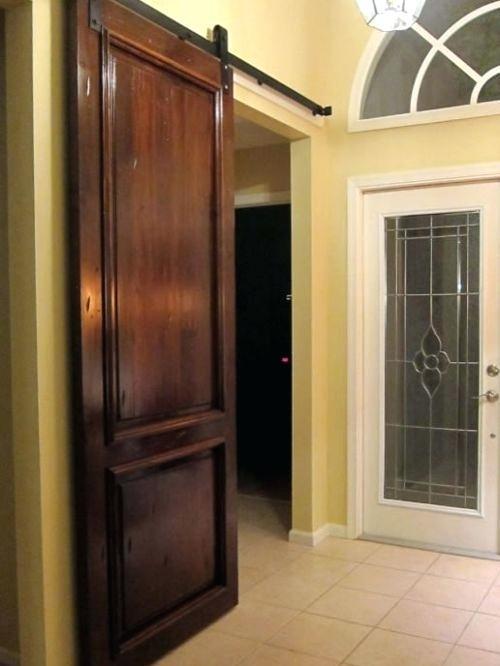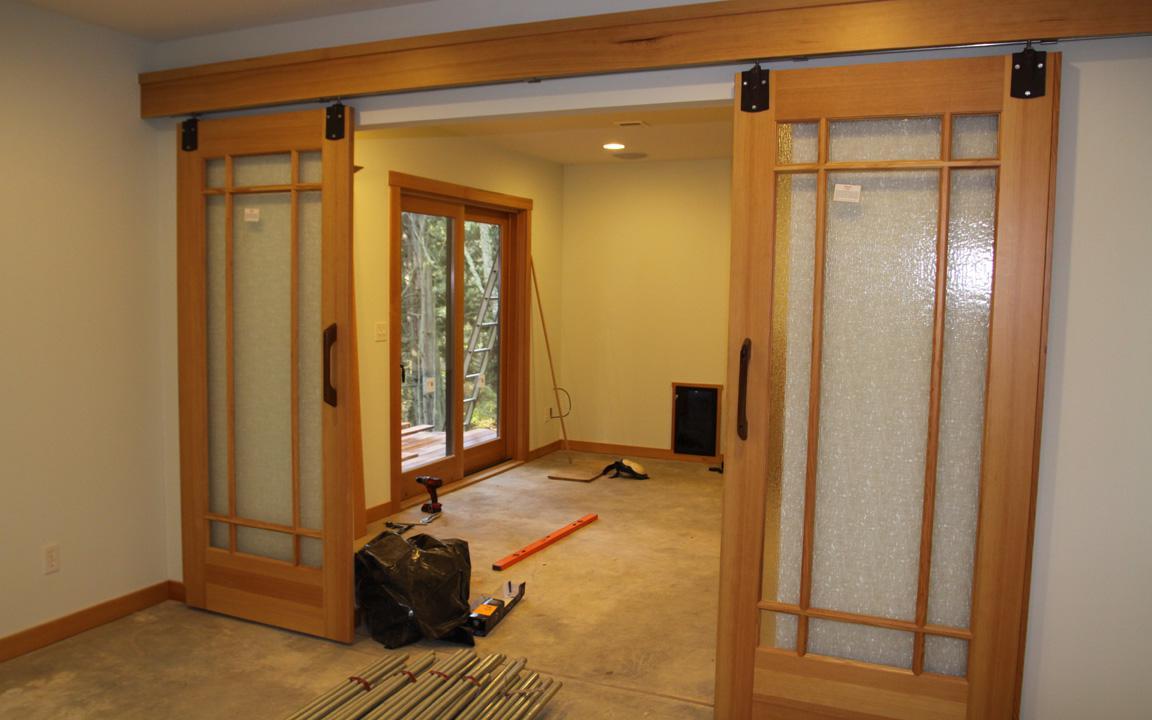The first image is the image on the left, the second image is the image on the right. Assess this claim about the two images: "THere is a total of two hanging doors.". Correct or not? Answer yes or no. No. 